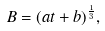Convert formula to latex. <formula><loc_0><loc_0><loc_500><loc_500>B = ( a t + b ) ^ { \frac { 1 } { 3 } } ,</formula> 